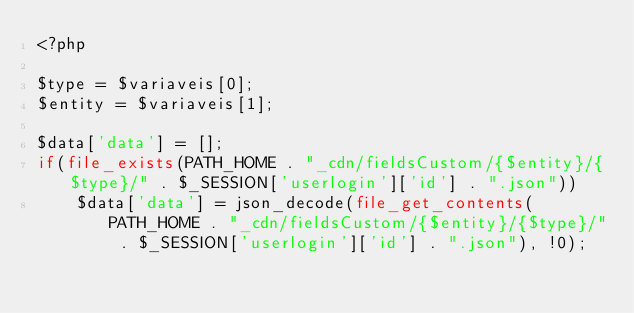<code> <loc_0><loc_0><loc_500><loc_500><_PHP_><?php

$type = $variaveis[0];
$entity = $variaveis[1];

$data['data'] = [];
if(file_exists(PATH_HOME . "_cdn/fieldsCustom/{$entity}/{$type}/" . $_SESSION['userlogin']['id'] . ".json"))
    $data['data'] = json_decode(file_get_contents(PATH_HOME . "_cdn/fieldsCustom/{$entity}/{$type}/" . $_SESSION['userlogin']['id'] . ".json"), !0);</code> 